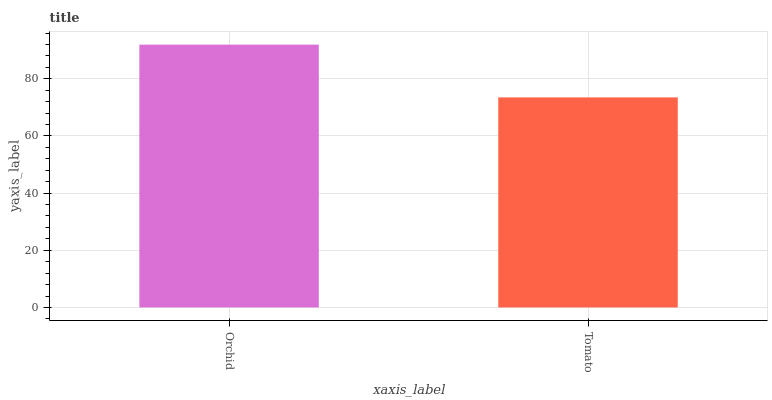Is Tomato the minimum?
Answer yes or no. Yes. Is Orchid the maximum?
Answer yes or no. Yes. Is Tomato the maximum?
Answer yes or no. No. Is Orchid greater than Tomato?
Answer yes or no. Yes. Is Tomato less than Orchid?
Answer yes or no. Yes. Is Tomato greater than Orchid?
Answer yes or no. No. Is Orchid less than Tomato?
Answer yes or no. No. Is Orchid the high median?
Answer yes or no. Yes. Is Tomato the low median?
Answer yes or no. Yes. Is Tomato the high median?
Answer yes or no. No. Is Orchid the low median?
Answer yes or no. No. 